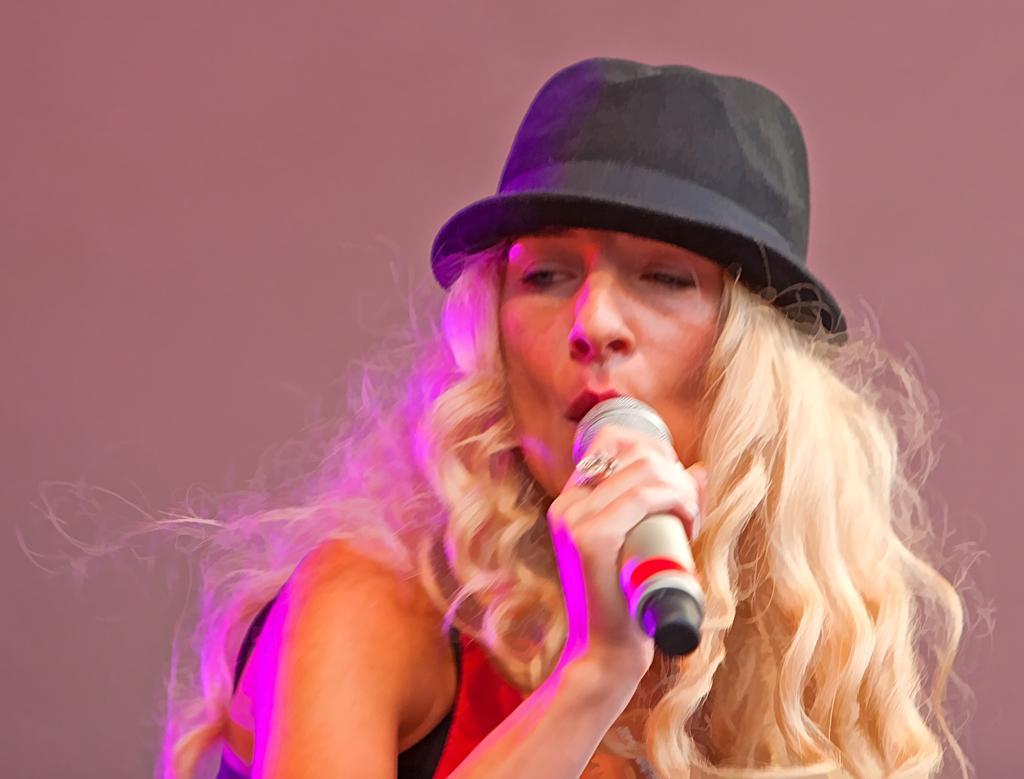In one or two sentences, can you explain what this image depicts? There is a woman who is singing with a mic in her hand and also woman has a cap on her head and a ring on her finger. 